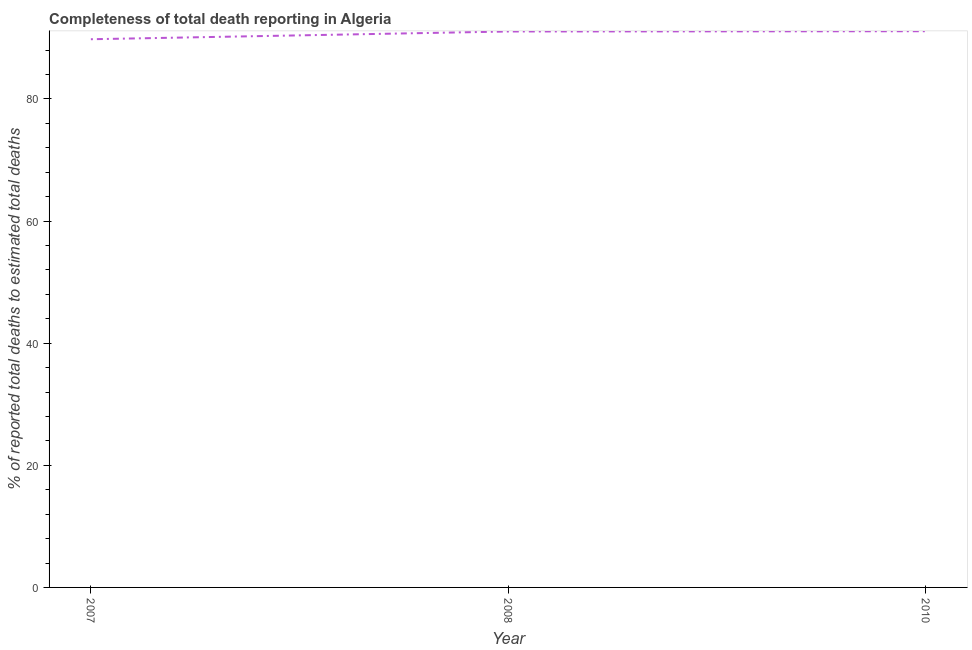What is the completeness of total death reports in 2010?
Offer a very short reply. 91.09. Across all years, what is the maximum completeness of total death reports?
Your answer should be compact. 91.09. Across all years, what is the minimum completeness of total death reports?
Your response must be concise. 89.77. In which year was the completeness of total death reports minimum?
Ensure brevity in your answer.  2007. What is the sum of the completeness of total death reports?
Your answer should be compact. 271.9. What is the difference between the completeness of total death reports in 2007 and 2010?
Make the answer very short. -1.31. What is the average completeness of total death reports per year?
Offer a very short reply. 90.63. What is the median completeness of total death reports?
Offer a very short reply. 91.04. Do a majority of the years between 2010 and 2008 (inclusive) have completeness of total death reports greater than 8 %?
Give a very brief answer. No. What is the ratio of the completeness of total death reports in 2007 to that in 2010?
Your answer should be very brief. 0.99. Is the completeness of total death reports in 2008 less than that in 2010?
Your answer should be very brief. Yes. Is the difference between the completeness of total death reports in 2007 and 2010 greater than the difference between any two years?
Ensure brevity in your answer.  Yes. What is the difference between the highest and the second highest completeness of total death reports?
Provide a short and direct response. 0.04. Is the sum of the completeness of total death reports in 2007 and 2008 greater than the maximum completeness of total death reports across all years?
Your answer should be compact. Yes. What is the difference between the highest and the lowest completeness of total death reports?
Give a very brief answer. 1.31. In how many years, is the completeness of total death reports greater than the average completeness of total death reports taken over all years?
Your answer should be compact. 2. Does the completeness of total death reports monotonically increase over the years?
Offer a very short reply. Yes. How many lines are there?
Make the answer very short. 1. How many years are there in the graph?
Give a very brief answer. 3. What is the difference between two consecutive major ticks on the Y-axis?
Your response must be concise. 20. Are the values on the major ticks of Y-axis written in scientific E-notation?
Provide a short and direct response. No. Does the graph contain any zero values?
Ensure brevity in your answer.  No. What is the title of the graph?
Your answer should be compact. Completeness of total death reporting in Algeria. What is the label or title of the Y-axis?
Keep it short and to the point. % of reported total deaths to estimated total deaths. What is the % of reported total deaths to estimated total deaths of 2007?
Your answer should be very brief. 89.77. What is the % of reported total deaths to estimated total deaths in 2008?
Provide a succinct answer. 91.04. What is the % of reported total deaths to estimated total deaths in 2010?
Make the answer very short. 91.09. What is the difference between the % of reported total deaths to estimated total deaths in 2007 and 2008?
Give a very brief answer. -1.27. What is the difference between the % of reported total deaths to estimated total deaths in 2007 and 2010?
Offer a very short reply. -1.31. What is the difference between the % of reported total deaths to estimated total deaths in 2008 and 2010?
Provide a short and direct response. -0.04. What is the ratio of the % of reported total deaths to estimated total deaths in 2007 to that in 2008?
Make the answer very short. 0.99. What is the ratio of the % of reported total deaths to estimated total deaths in 2007 to that in 2010?
Your answer should be compact. 0.99. What is the ratio of the % of reported total deaths to estimated total deaths in 2008 to that in 2010?
Provide a succinct answer. 1. 